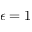<formula> <loc_0><loc_0><loc_500><loc_500>\epsilon = 1</formula> 